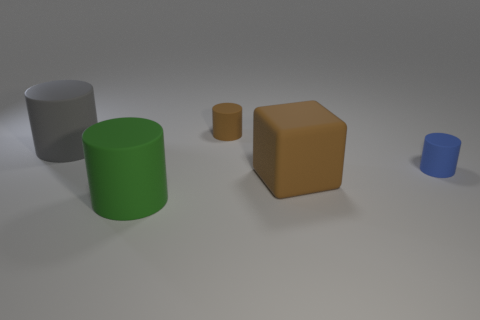Subtract all green rubber cylinders. How many cylinders are left? 3 Subtract 1 blocks. How many blocks are left? 0 Add 2 big brown metallic cylinders. How many objects exist? 7 Subtract all red spheres. How many blue cylinders are left? 1 Add 1 small blue cylinders. How many small blue cylinders are left? 2 Add 2 small gray spheres. How many small gray spheres exist? 2 Subtract all gray cylinders. How many cylinders are left? 3 Subtract 1 gray cylinders. How many objects are left? 4 Subtract all blocks. How many objects are left? 4 Subtract all cyan cylinders. Subtract all red balls. How many cylinders are left? 4 